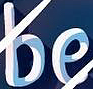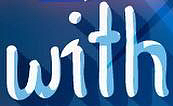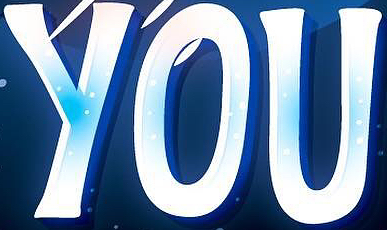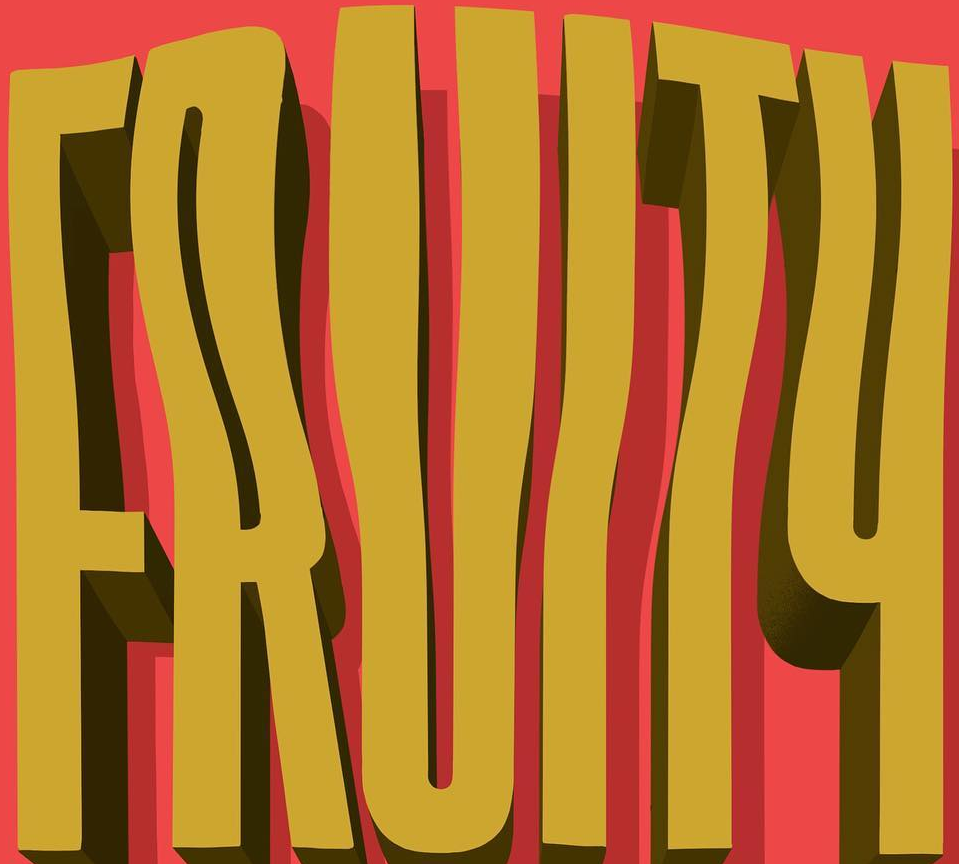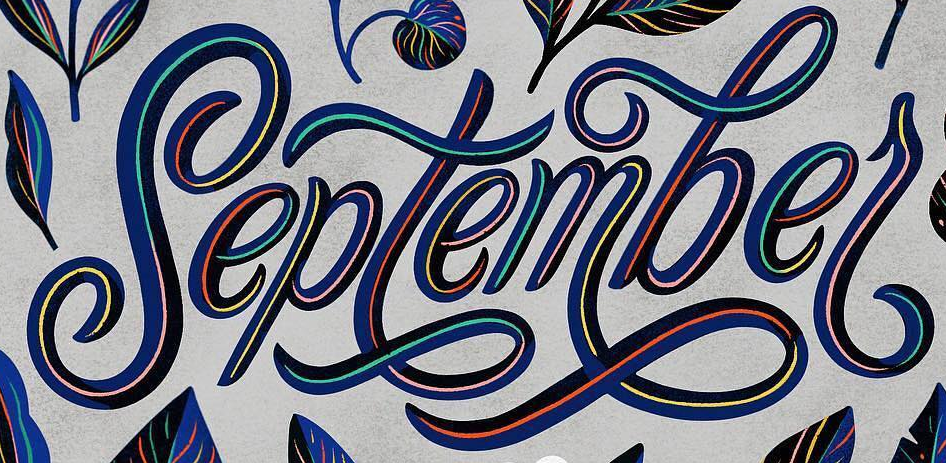Read the text content from these images in order, separated by a semicolon. be; with; YOU; FRUITY; septembel 